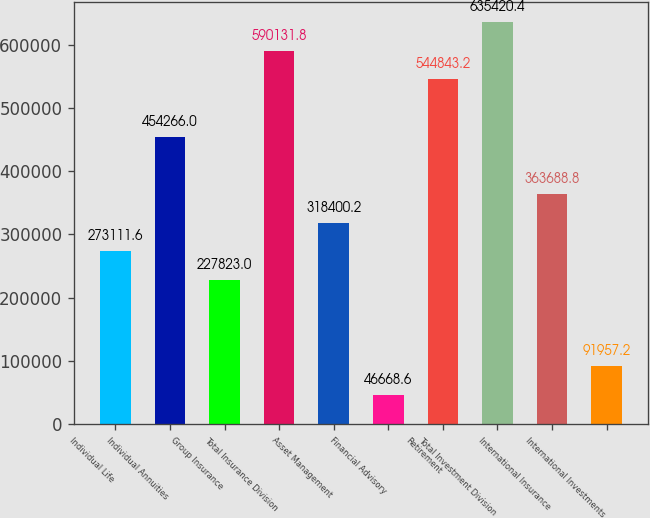Convert chart to OTSL. <chart><loc_0><loc_0><loc_500><loc_500><bar_chart><fcel>Individual Life<fcel>Individual Annuities<fcel>Group Insurance<fcel>Total Insurance Division<fcel>Asset Management<fcel>Financial Advisory<fcel>Retirement<fcel>Total Investment Division<fcel>International Insurance<fcel>International Investments<nl><fcel>273112<fcel>454266<fcel>227823<fcel>590132<fcel>318400<fcel>46668.6<fcel>544843<fcel>635420<fcel>363689<fcel>91957.2<nl></chart> 